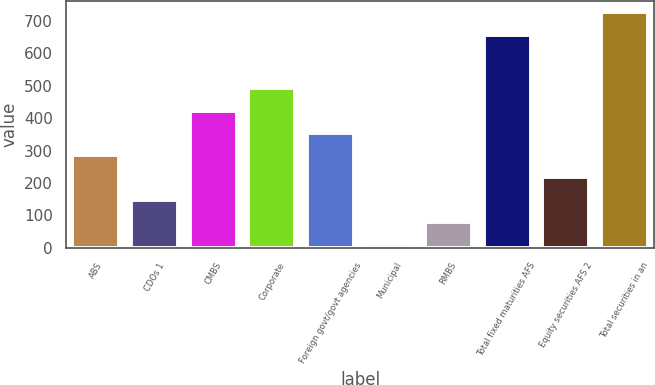Convert chart to OTSL. <chart><loc_0><loc_0><loc_500><loc_500><bar_chart><fcel>ABS<fcel>CDOs 1<fcel>CMBS<fcel>Corporate<fcel>Foreign govt/govt agencies<fcel>Municipal<fcel>RMBS<fcel>Total fixed maturities AFS<fcel>Equity securities AFS 2<fcel>Total securities in an<nl><fcel>286.2<fcel>148.6<fcel>423.8<fcel>492.6<fcel>355<fcel>11<fcel>79.8<fcel>658<fcel>217.4<fcel>726.8<nl></chart> 